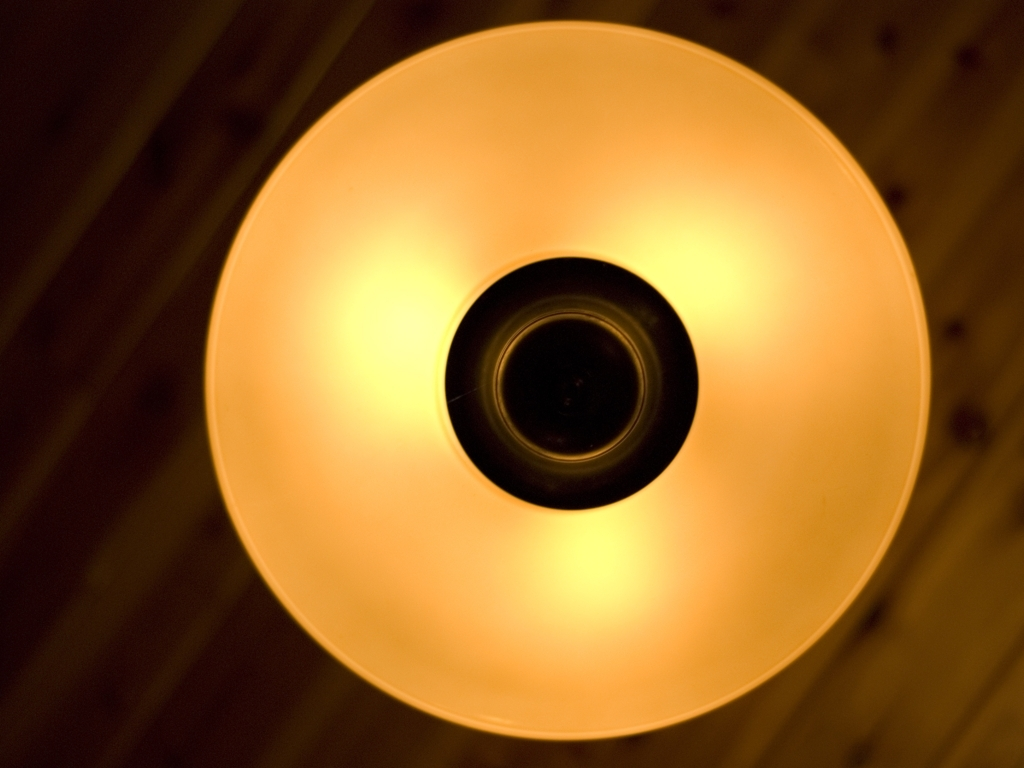What might be the function of this light fixture in its setting? This particular light fixture appears to be designed for ambient lighting, providing a gentle illumination that enhances the ambiance of a space without causing glare. It could be utilized in residential or commercial spaces where soft lighting is desired for creating a warm, welcoming environment. 